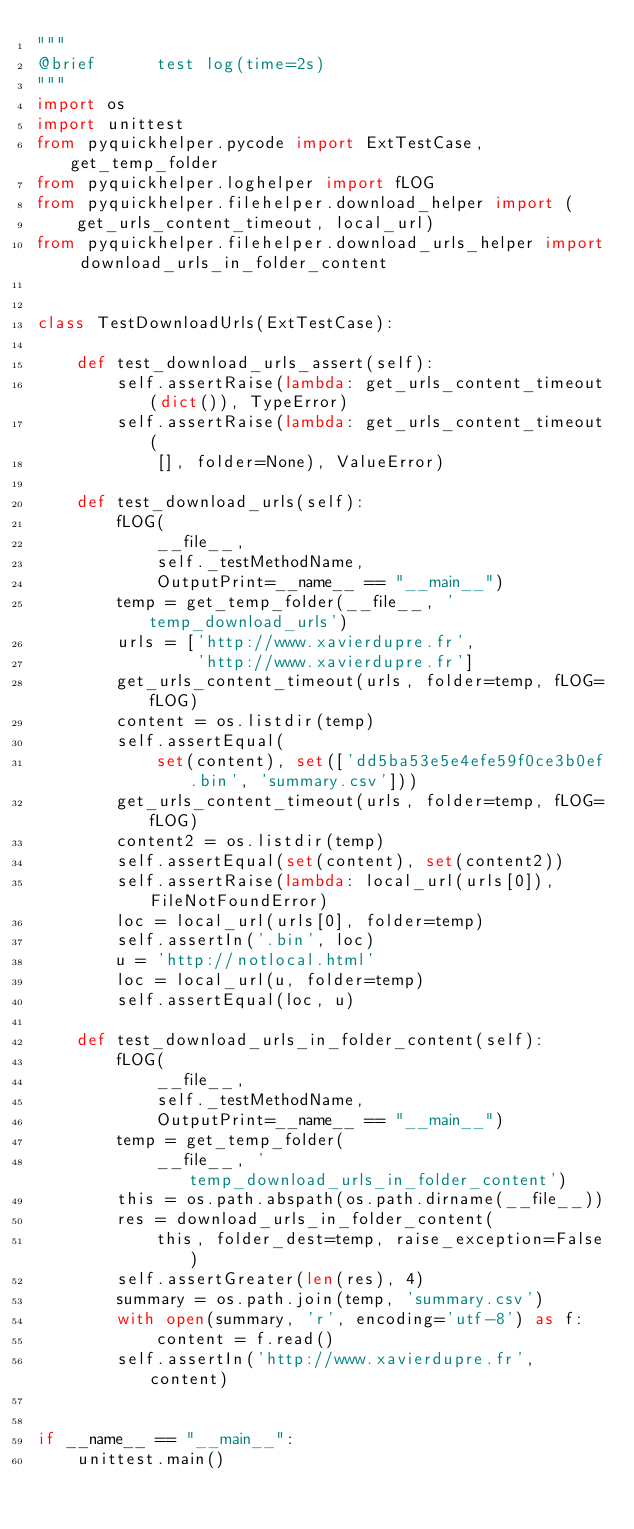<code> <loc_0><loc_0><loc_500><loc_500><_Python_>"""
@brief      test log(time=2s)
"""
import os
import unittest
from pyquickhelper.pycode import ExtTestCase, get_temp_folder
from pyquickhelper.loghelper import fLOG
from pyquickhelper.filehelper.download_helper import (
    get_urls_content_timeout, local_url)
from pyquickhelper.filehelper.download_urls_helper import download_urls_in_folder_content


class TestDownloadUrls(ExtTestCase):

    def test_download_urls_assert(self):
        self.assertRaise(lambda: get_urls_content_timeout(dict()), TypeError)
        self.assertRaise(lambda: get_urls_content_timeout(
            [], folder=None), ValueError)

    def test_download_urls(self):
        fLOG(
            __file__,
            self._testMethodName,
            OutputPrint=__name__ == "__main__")
        temp = get_temp_folder(__file__, 'temp_download_urls')
        urls = ['http://www.xavierdupre.fr',
                'http://www.xavierdupre.fr']
        get_urls_content_timeout(urls, folder=temp, fLOG=fLOG)
        content = os.listdir(temp)
        self.assertEqual(
            set(content), set(['dd5ba53e5e4efe59f0ce3b0ef.bin', 'summary.csv']))
        get_urls_content_timeout(urls, folder=temp, fLOG=fLOG)
        content2 = os.listdir(temp)
        self.assertEqual(set(content), set(content2))
        self.assertRaise(lambda: local_url(urls[0]), FileNotFoundError)
        loc = local_url(urls[0], folder=temp)
        self.assertIn('.bin', loc)
        u = 'http://notlocal.html'
        loc = local_url(u, folder=temp)
        self.assertEqual(loc, u)

    def test_download_urls_in_folder_content(self):
        fLOG(
            __file__,
            self._testMethodName,
            OutputPrint=__name__ == "__main__")
        temp = get_temp_folder(
            __file__, 'temp_download_urls_in_folder_content')
        this = os.path.abspath(os.path.dirname(__file__))
        res = download_urls_in_folder_content(
            this, folder_dest=temp, raise_exception=False)
        self.assertGreater(len(res), 4)
        summary = os.path.join(temp, 'summary.csv')
        with open(summary, 'r', encoding='utf-8') as f:
            content = f.read()
        self.assertIn('http://www.xavierdupre.fr', content)


if __name__ == "__main__":
    unittest.main()
</code> 